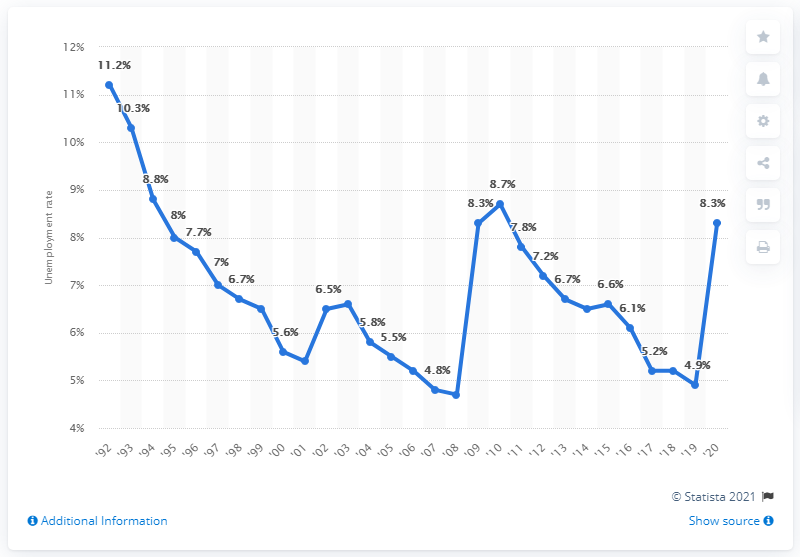Indicate a few pertinent items in this graphic. In 1992, the unemployment rate in West Virginia was 4.9%. In 2020, the unemployment rate in West Virginia was 8.3%. 